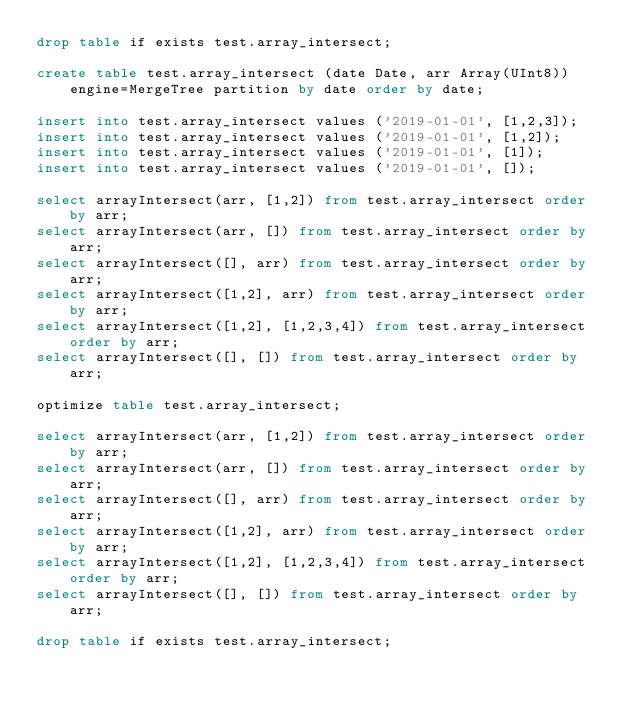Convert code to text. <code><loc_0><loc_0><loc_500><loc_500><_SQL_>drop table if exists test.array_intersect;

create table test.array_intersect (date Date, arr Array(UInt8)) engine=MergeTree partition by date order by date;

insert into test.array_intersect values ('2019-01-01', [1,2,3]);
insert into test.array_intersect values ('2019-01-01', [1,2]);
insert into test.array_intersect values ('2019-01-01', [1]);
insert into test.array_intersect values ('2019-01-01', []);

select arrayIntersect(arr, [1,2]) from test.array_intersect order by arr;
select arrayIntersect(arr, []) from test.array_intersect order by arr;
select arrayIntersect([], arr) from test.array_intersect order by arr;
select arrayIntersect([1,2], arr) from test.array_intersect order by arr;
select arrayIntersect([1,2], [1,2,3,4]) from test.array_intersect order by arr;
select arrayIntersect([], []) from test.array_intersect order by arr;

optimize table test.array_intersect;

select arrayIntersect(arr, [1,2]) from test.array_intersect order by arr;
select arrayIntersect(arr, []) from test.array_intersect order by arr;
select arrayIntersect([], arr) from test.array_intersect order by arr;
select arrayIntersect([1,2], arr) from test.array_intersect order by arr;
select arrayIntersect([1,2], [1,2,3,4]) from test.array_intersect order by arr;
select arrayIntersect([], []) from test.array_intersect order by arr;

drop table if exists test.array_intersect;

</code> 